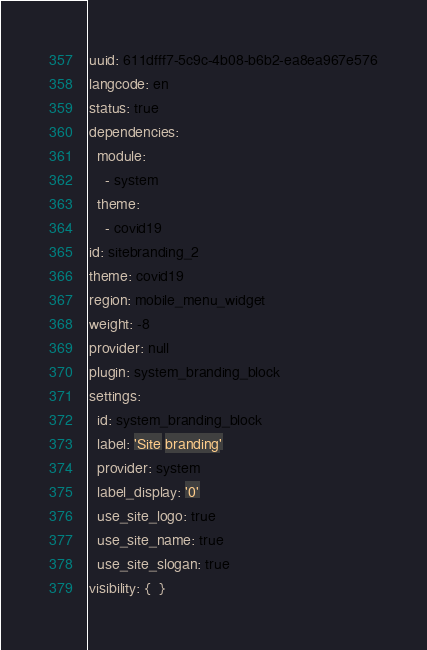Convert code to text. <code><loc_0><loc_0><loc_500><loc_500><_YAML_>uuid: 611dfff7-5c9c-4b08-b6b2-ea8ea967e576
langcode: en
status: true
dependencies:
  module:
    - system
  theme:
    - covid19
id: sitebranding_2
theme: covid19
region: mobile_menu_widget
weight: -8
provider: null
plugin: system_branding_block
settings:
  id: system_branding_block
  label: 'Site branding'
  provider: system
  label_display: '0'
  use_site_logo: true
  use_site_name: true
  use_site_slogan: true
visibility: {  }
</code> 